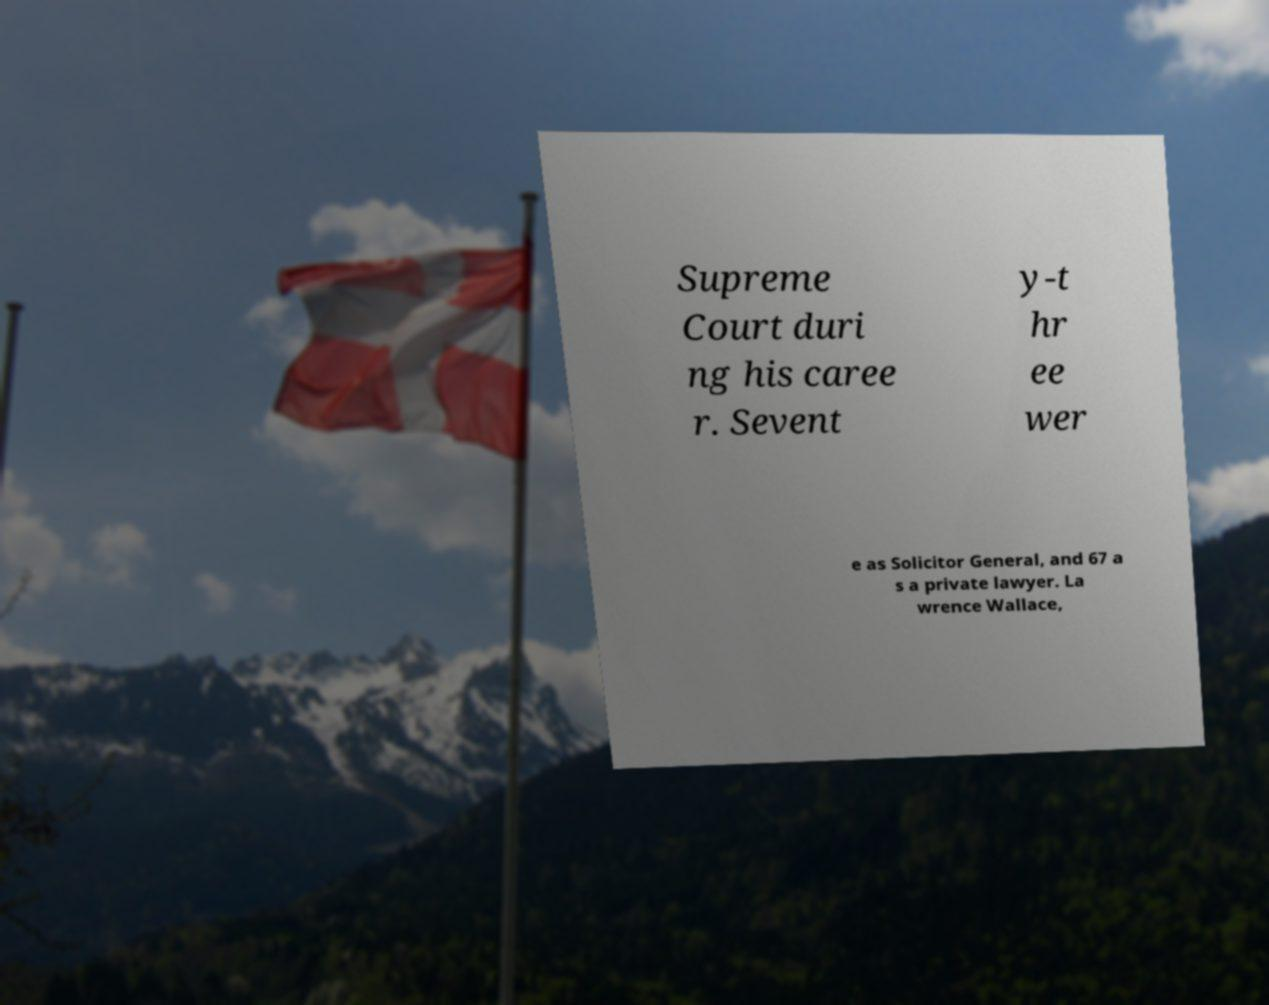Please identify and transcribe the text found in this image. Supreme Court duri ng his caree r. Sevent y-t hr ee wer e as Solicitor General, and 67 a s a private lawyer. La wrence Wallace, 